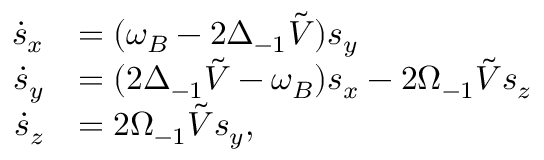Convert formula to latex. <formula><loc_0><loc_0><loc_500><loc_500>\begin{array} { r l } { \dot { s } _ { x } } & { = ( \omega _ { B } - 2 \Delta _ { - 1 } \tilde { V } ) s _ { y } } \\ { \dot { s } _ { y } } & { = ( 2 \Delta _ { - 1 } \tilde { V } - \omega _ { B } ) s _ { x } - 2 \Omega _ { - 1 } \tilde { V } s _ { z } } \\ { \dot { s } _ { z } } & { = 2 \Omega _ { - 1 } \tilde { V } s _ { y } , } \end{array}</formula> 